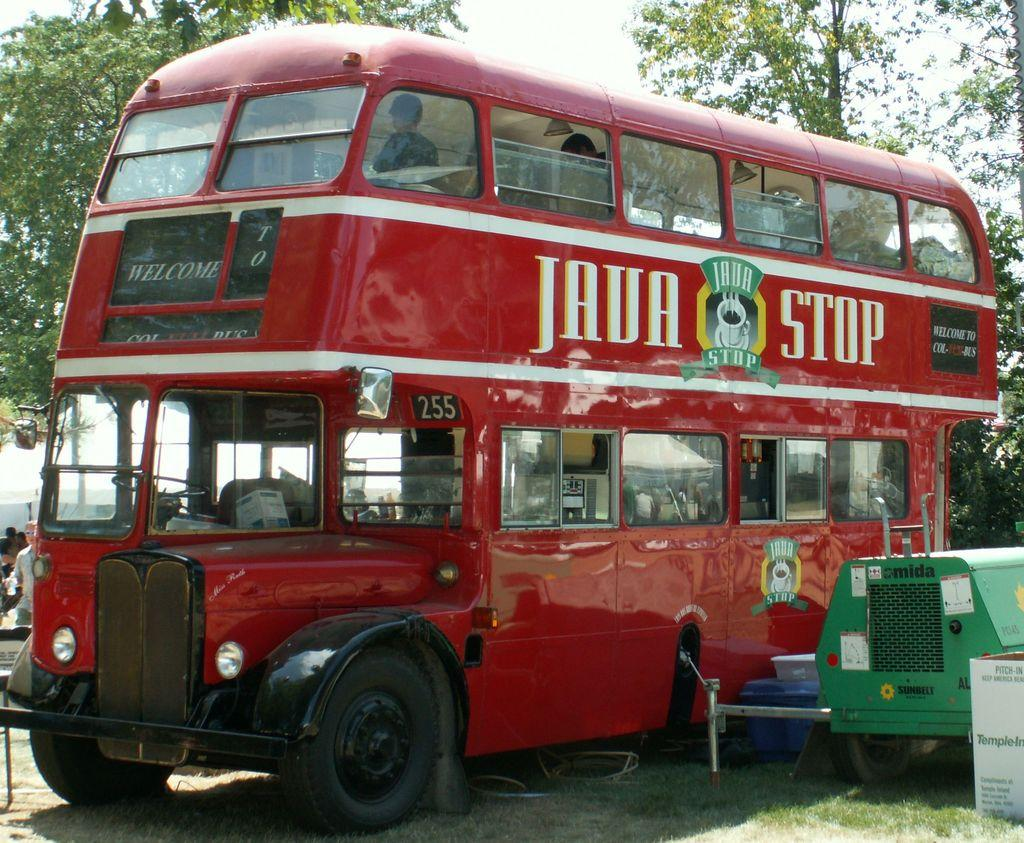What type of vehicle is the main subject in the image? There is a red double-decker bus in the image. What other vehicle can be seen in the image? There is a vehicle on the right side of the image. What type of natural scenery is visible in the image? There are trees visible in the image. What is visible in the background of the image? The sky is visible in the image. What type of knife is the toad holding in the image? There is no toad or knife present in the image. What type of gun can be seen in the image? There is no gun present in the image. 